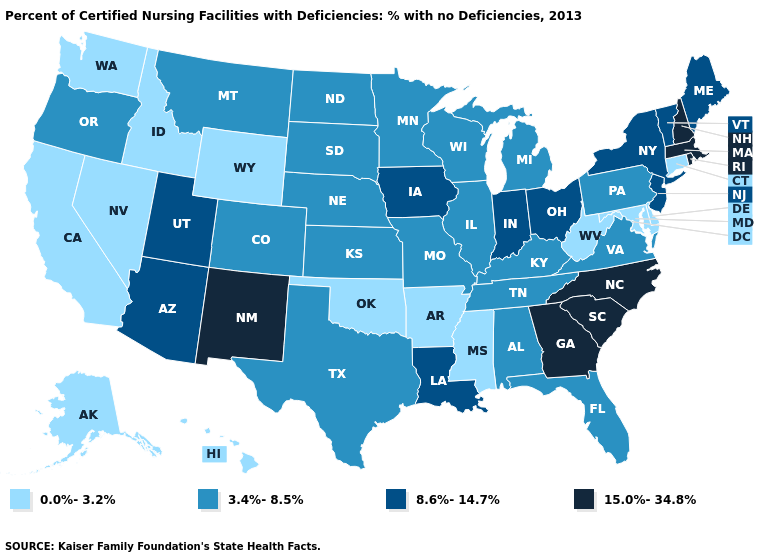What is the value of Massachusetts?
Quick response, please. 15.0%-34.8%. Name the states that have a value in the range 15.0%-34.8%?
Answer briefly. Georgia, Massachusetts, New Hampshire, New Mexico, North Carolina, Rhode Island, South Carolina. Does Alaska have the highest value in the USA?
Be succinct. No. Name the states that have a value in the range 15.0%-34.8%?
Quick response, please. Georgia, Massachusetts, New Hampshire, New Mexico, North Carolina, Rhode Island, South Carolina. Which states have the lowest value in the USA?
Short answer required. Alaska, Arkansas, California, Connecticut, Delaware, Hawaii, Idaho, Maryland, Mississippi, Nevada, Oklahoma, Washington, West Virginia, Wyoming. Does the first symbol in the legend represent the smallest category?
Be succinct. Yes. Which states have the lowest value in the USA?
Answer briefly. Alaska, Arkansas, California, Connecticut, Delaware, Hawaii, Idaho, Maryland, Mississippi, Nevada, Oklahoma, Washington, West Virginia, Wyoming. What is the value of Hawaii?
Answer briefly. 0.0%-3.2%. What is the highest value in the USA?
Concise answer only. 15.0%-34.8%. Name the states that have a value in the range 0.0%-3.2%?
Keep it brief. Alaska, Arkansas, California, Connecticut, Delaware, Hawaii, Idaho, Maryland, Mississippi, Nevada, Oklahoma, Washington, West Virginia, Wyoming. What is the value of Tennessee?
Answer briefly. 3.4%-8.5%. Does Nevada have the highest value in the West?
Give a very brief answer. No. What is the value of Colorado?
Quick response, please. 3.4%-8.5%. What is the value of Kentucky?
Concise answer only. 3.4%-8.5%. Name the states that have a value in the range 15.0%-34.8%?
Quick response, please. Georgia, Massachusetts, New Hampshire, New Mexico, North Carolina, Rhode Island, South Carolina. 